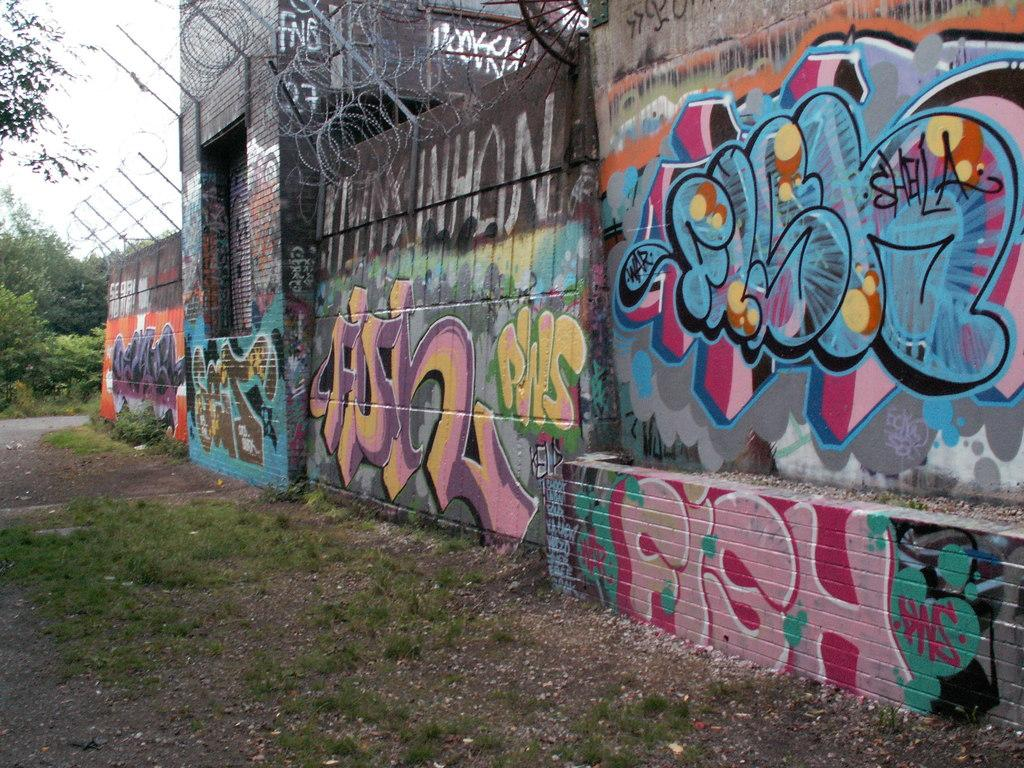What type of structure is present in the image? There is a building in the image. What is the purpose of the wall in the image? The wall serves as a barrier or boundary in the image. What type of artwork can be seen in the image? There are paintings in the image. What type of vegetation is present in the image? There are trees and grass in the image. What are the poles used for in the image? The poles may be used for support or as markers in the image. What is the purpose of the fence in the image? The fence serves as a barrier or boundary in the image. What can be seen in the background of the image? The sky is visible in the background of the image. How many pizzas are being served in the image? There are no pizzas present in the image. What type of geese can be seen flying in the sky in the image? There are no geese visible in the sky in the image. 